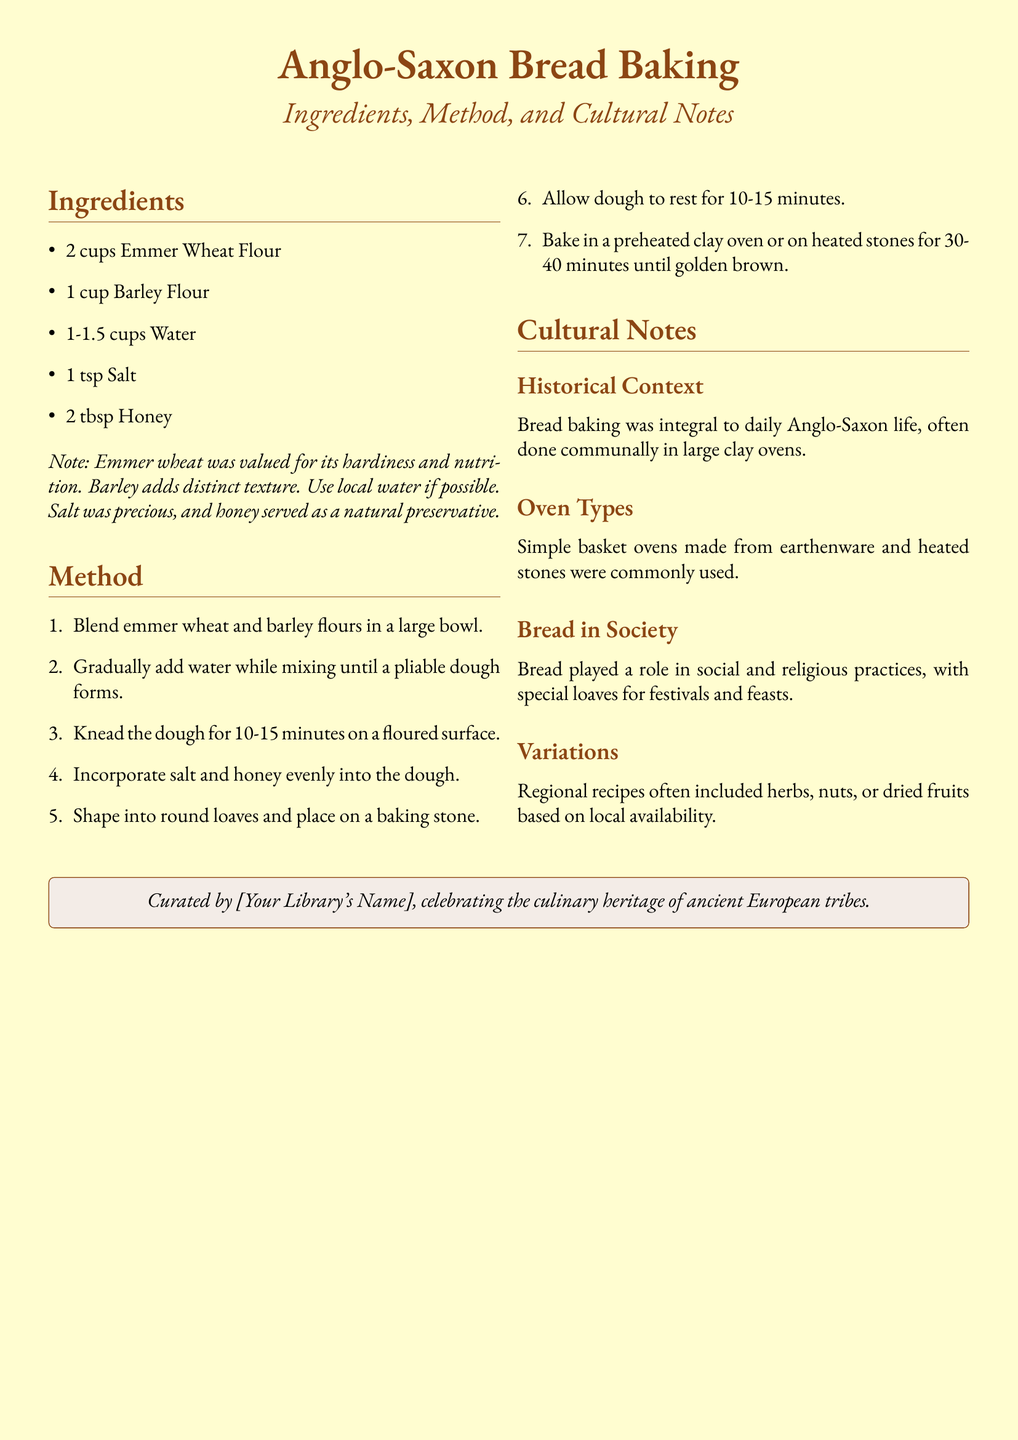what types of flour are used? The document lists the ingredients required for the recipe, specifically mentioning Emmer Wheat Flour and Barley Flour.
Answer: Emmer Wheat Flour, Barley Flour how much honey is needed? The ingredients section provides the quantity of honey required for the recipe, which is stated clearly.
Answer: 2 tbsp what is the baking time for the bread? The method section outlines the duration for baking the bread, providing this crucial information.
Answer: 30-40 minutes what was the role of bread in Anglo-Saxon society? The cultural notes section discusses the societal significance of bread, indicating its use in various practices.
Answer: Social and religious practices why was honey used in the recipe? The cultural notes describe the purpose of honey in the recipe, particularly regarding preservation.
Answer: Natural preservative how long should the dough rest after shaping? The method specifies the resting time required for the shaped dough before baking.
Answer: 10-15 minutes which type of oven was commonly used for baking? The cultural notes provide information about the types of ovens used historically for baking bread.
Answer: Clay ovens what is the total amount of water needed for the recipe? The ingredients section specifies the range of water quantity required for the recipe.
Answer: 1-1.5 cups 